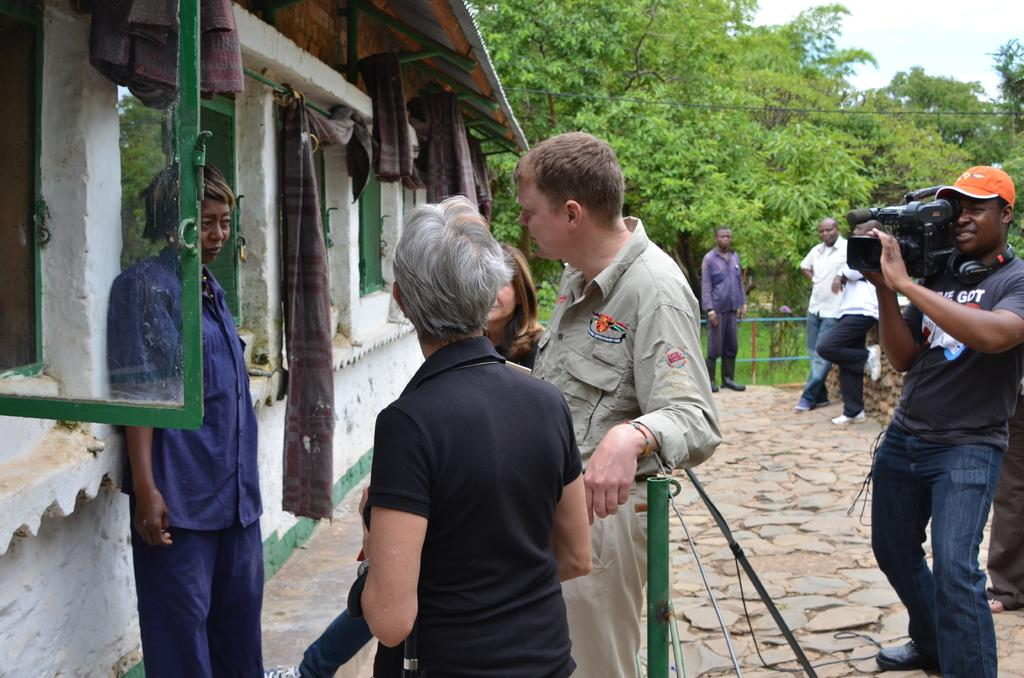What is happening in the image involving a group of people? The people are performing an act in the image. Where are the people located in relation to the building? The people are standing in front of a building. Who is capturing the act with a camera? One person is capturing the act with a camera. What can be seen in the background of the image? There are many trees around the group of people. What type of insurance policy do the people in the image have? There is no information about insurance policies in the image. Is there a maid present in the image? There is no mention of a maid in the image. 